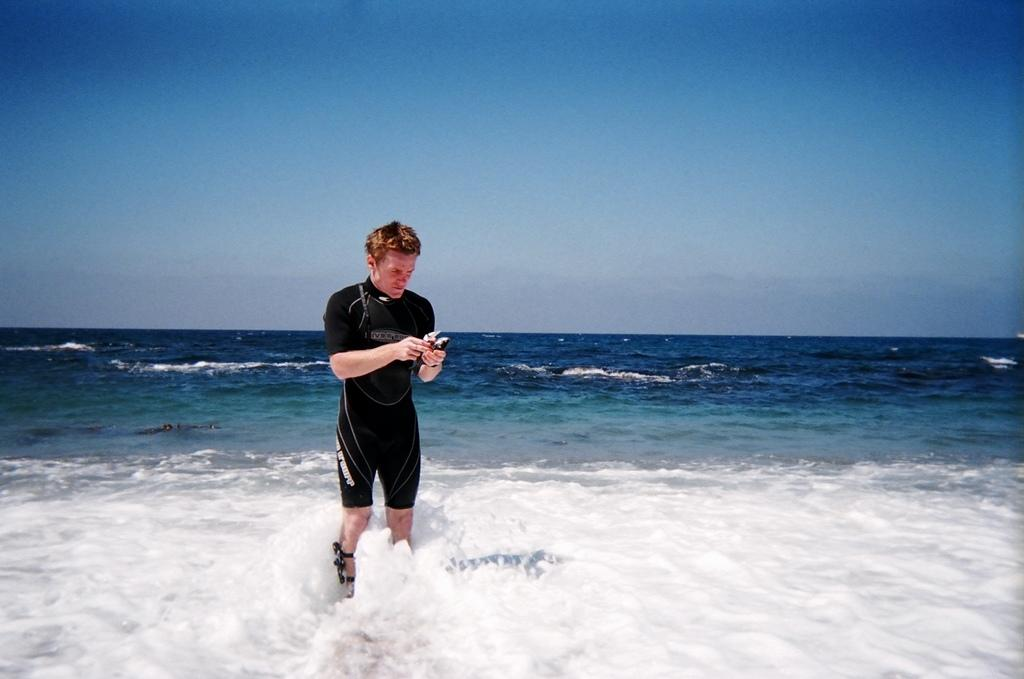What is the person in the image doing? The person is standing on the water in the image. What is the person wearing? The person is wearing a black dress. What is the person holding in their hands? The person is holding an object in their hands. What can be seen in the sky in the image? The sky is visible at the top of the image. Where is the goat located in the image? There is no goat present in the image. What type of attraction is featured in the image? The image does not depict any specific attraction; it shows a person standing on water. 